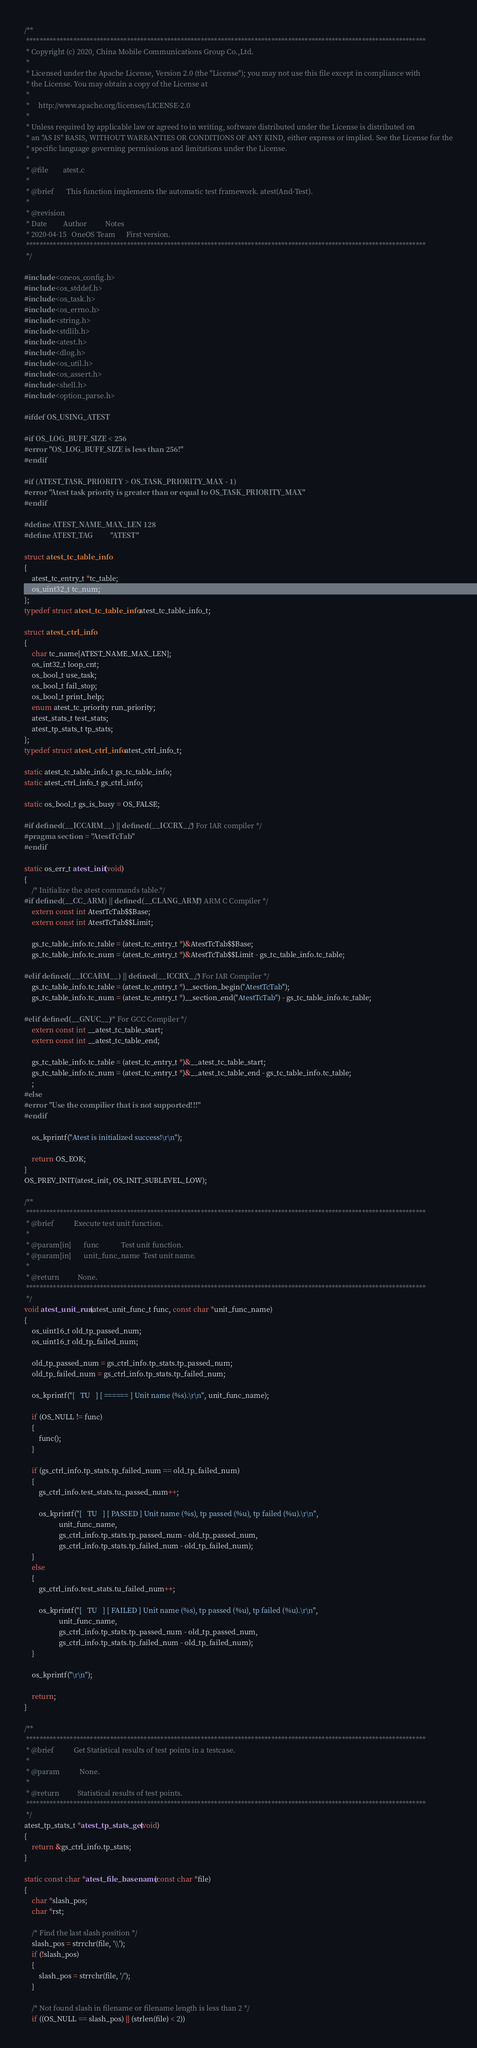<code> <loc_0><loc_0><loc_500><loc_500><_C_>/**
 ***********************************************************************************************************************
 * Copyright (c) 2020, China Mobile Communications Group Co.,Ltd.
 *
 * Licensed under the Apache License, Version 2.0 (the "License"); you may not use this file except in compliance with
 * the License. You may obtain a copy of the License at
 *
 *     http://www.apache.org/licenses/LICENSE-2.0
 *
 * Unless required by applicable law or agreed to in writing, software distributed under the License is distributed on
 * an "AS IS" BASIS, WITHOUT WARRANTIES OR CONDITIONS OF ANY KIND, either express or implied. See the License for the
 * specific language governing permissions and limitations under the License.
 *
 * @file        atest.c
 *
 * @brief       This function implements the automatic test framework. atest(And-Test).
 *
 * @revision
 * Date         Author          Notes
 * 2020-04-15   OneOS Team      First version.
 ***********************************************************************************************************************
 */

#include <oneos_config.h>
#include <os_stddef.h>
#include <os_task.h>
#include <os_errno.h>
#include <string.h>
#include <stdlib.h>
#include <atest.h>
#include <dlog.h>
#include <os_util.h>
#include <os_assert.h>
#include <shell.h>
#include <option_parse.h>

#ifdef OS_USING_ATEST

#if OS_LOG_BUFF_SIZE < 256
#error "OS_LOG_BUFF_SIZE is less than 256!"
#endif

#if (ATEST_TASK_PRIORITY > OS_TASK_PRIORITY_MAX - 1)
#error "Atest task priority is greater than or equal to OS_TASK_PRIORITY_MAX"
#endif

#define ATEST_NAME_MAX_LEN 128
#define ATEST_TAG          "ATEST"

struct atest_tc_table_info
{
    atest_tc_entry_t *tc_table;
    os_uint32_t tc_num;
};
typedef struct atest_tc_table_info atest_tc_table_info_t;

struct atest_ctrl_info
{
    char tc_name[ATEST_NAME_MAX_LEN];
    os_int32_t loop_cnt;
    os_bool_t use_task;
    os_bool_t fail_stop;
    os_bool_t print_help;
    enum atest_tc_priority run_priority;
    atest_stats_t test_stats;
    atest_tp_stats_t tp_stats;
};
typedef struct atest_ctrl_info atest_ctrl_info_t;

static atest_tc_table_info_t gs_tc_table_info;
static atest_ctrl_info_t gs_ctrl_info;

static os_bool_t gs_is_busy = OS_FALSE;

#if defined(__ICCARM__) || defined(__ICCRX__) /* For IAR compiler */
#pragma section = "AtestTcTab"
#endif

static os_err_t atest_init(void)
{
    /* Initialize the atest commands table.*/
#if defined(__CC_ARM) || defined(__CLANG_ARM) /* ARM C Compiler */
    extern const int AtestTcTab$$Base;
    extern const int AtestTcTab$$Limit;

    gs_tc_table_info.tc_table = (atest_tc_entry_t *)&AtestTcTab$$Base;
    gs_tc_table_info.tc_num = (atest_tc_entry_t *)&AtestTcTab$$Limit - gs_tc_table_info.tc_table;

#elif defined(__ICCARM__) || defined(__ICCRX__) /* For IAR Compiler */
    gs_tc_table_info.tc_table = (atest_tc_entry_t *)__section_begin("AtestTcTab");
    gs_tc_table_info.tc_num = (atest_tc_entry_t *)__section_end("AtestTcTab") - gs_tc_table_info.tc_table;

#elif defined(__GNUC__) /* For GCC Compiler */
    extern const int __atest_tc_table_start;
    extern const int __atest_tc_table_end;

    gs_tc_table_info.tc_table = (atest_tc_entry_t *)&__atest_tc_table_start;
    gs_tc_table_info.tc_num = (atest_tc_entry_t *)&__atest_tc_table_end - gs_tc_table_info.tc_table;
    ;
#else
#error "Use the compilier that is not supported!!!"
#endif

    os_kprintf("Atest is initialized success!\r\n");

    return OS_EOK;
}
OS_PREV_INIT(atest_init, OS_INIT_SUBLEVEL_LOW);

/**
 ***********************************************************************************************************************
 * @brief           Execute test unit function.
 *
 * @param[in]       func            Test unit function.
 * @param[in]       unit_func_name  Test unit name.
 *
 * @return          None.
 ***********************************************************************************************************************
 */
void atest_unit_run(atest_unit_func_t func, const char *unit_func_name)
{
    os_uint16_t old_tp_passed_num;
    os_uint16_t old_tp_failed_num;

    old_tp_passed_num = gs_ctrl_info.tp_stats.tp_passed_num;
    old_tp_failed_num = gs_ctrl_info.tp_stats.tp_failed_num;

    os_kprintf("[   TU   ] [ ====== ] Unit name (%s).\r\n", unit_func_name);

    if (OS_NULL != func)
    {
        func();
    }

    if (gs_ctrl_info.tp_stats.tp_failed_num == old_tp_failed_num)
    {
        gs_ctrl_info.test_stats.tu_passed_num++;

        os_kprintf("[   TU   ] [ PASSED ] Unit name (%s), tp passed (%u), tp failed (%u).\r\n",
                   unit_func_name,
                   gs_ctrl_info.tp_stats.tp_passed_num - old_tp_passed_num,
                   gs_ctrl_info.tp_stats.tp_failed_num - old_tp_failed_num);
    }
    else
    {
        gs_ctrl_info.test_stats.tu_failed_num++;

        os_kprintf("[   TU   ] [ FAILED ] Unit name (%s), tp passed (%u), tp failed (%u).\r\n",
                   unit_func_name,
                   gs_ctrl_info.tp_stats.tp_passed_num - old_tp_passed_num,
                   gs_ctrl_info.tp_stats.tp_failed_num - old_tp_failed_num);
    }

    os_kprintf("\r\n");

    return;
}

/**
 ***********************************************************************************************************************
 * @brief           Get Statistical results of test points in a testcase.
 *
 * @param           None.
 *
 * @return          Statistical results of test points.
 ***********************************************************************************************************************
 */
atest_tp_stats_t *atest_tp_stats_get(void)
{
    return &gs_ctrl_info.tp_stats;
}

static const char *atest_file_basename(const char *file)
{
    char *slash_pos;
    char *rst;

    /* Find the last slash position */
    slash_pos = strrchr(file, '\\');
    if (!slash_pos)
    {
        slash_pos = strrchr(file, '/');
    }

    /* Not found slash in filename or filename length is less than 2 */
    if ((OS_NULL == slash_pos) || (strlen(file) < 2))</code> 